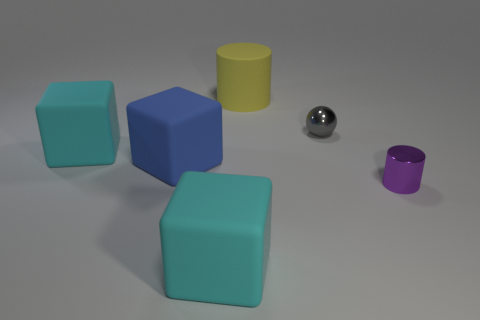Does the big cylinder have the same material as the cyan block that is on the right side of the big blue rubber block?
Make the answer very short. Yes. What color is the thing that is behind the small metal object that is behind the cylinder right of the matte cylinder?
Ensure brevity in your answer.  Yellow. What shape is the blue rubber thing that is the same size as the yellow matte thing?
Provide a short and direct response. Cube. Is there anything else that is the same size as the yellow rubber cylinder?
Give a very brief answer. Yes. Is the size of the metal thing that is to the left of the purple object the same as the metal thing that is in front of the tiny gray metal sphere?
Offer a terse response. Yes. How big is the cylinder that is behind the tiny ball?
Keep it short and to the point. Large. What is the color of the cylinder that is the same size as the blue rubber block?
Your answer should be compact. Yellow. Does the blue matte object have the same size as the yellow object?
Make the answer very short. Yes. How big is the object that is in front of the large blue matte thing and left of the big yellow thing?
Provide a short and direct response. Large. What number of rubber things are large yellow cylinders or purple objects?
Offer a very short reply. 1. 